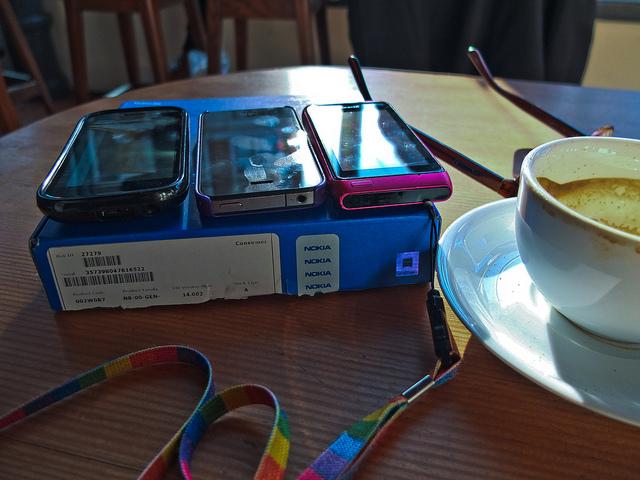Is this someone's breakfast?
Be succinct. No. What is in the photo that helps with reading?
Keep it brief. Glasses. How many cell phones are there?
Be succinct. 3. What is in the cup?
Give a very brief answer. Coffee. 